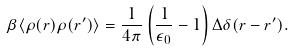Convert formula to latex. <formula><loc_0><loc_0><loc_500><loc_500>\beta \langle \rho ( { r } ) \rho ( { r } ^ { \prime } ) \rangle = \frac { 1 } { 4 \pi } \left ( \frac { 1 } { \epsilon _ { 0 } } - 1 \right ) \Delta \delta ( { r } - { r } ^ { \prime } ) .</formula> 